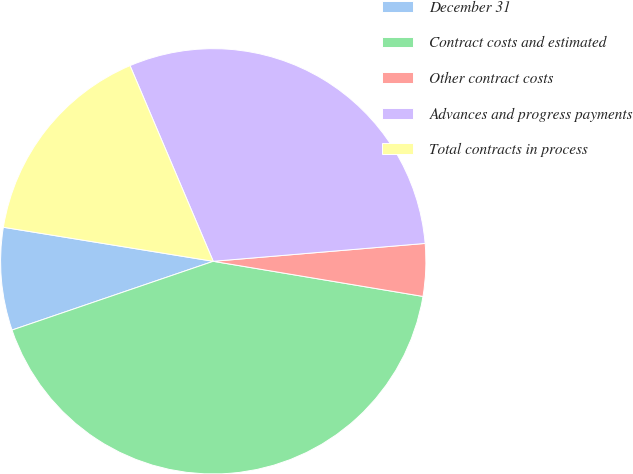<chart> <loc_0><loc_0><loc_500><loc_500><pie_chart><fcel>December 31<fcel>Contract costs and estimated<fcel>Other contract costs<fcel>Advances and progress payments<fcel>Total contracts in process<nl><fcel>7.8%<fcel>42.12%<fcel>3.98%<fcel>30.06%<fcel>16.04%<nl></chart> 